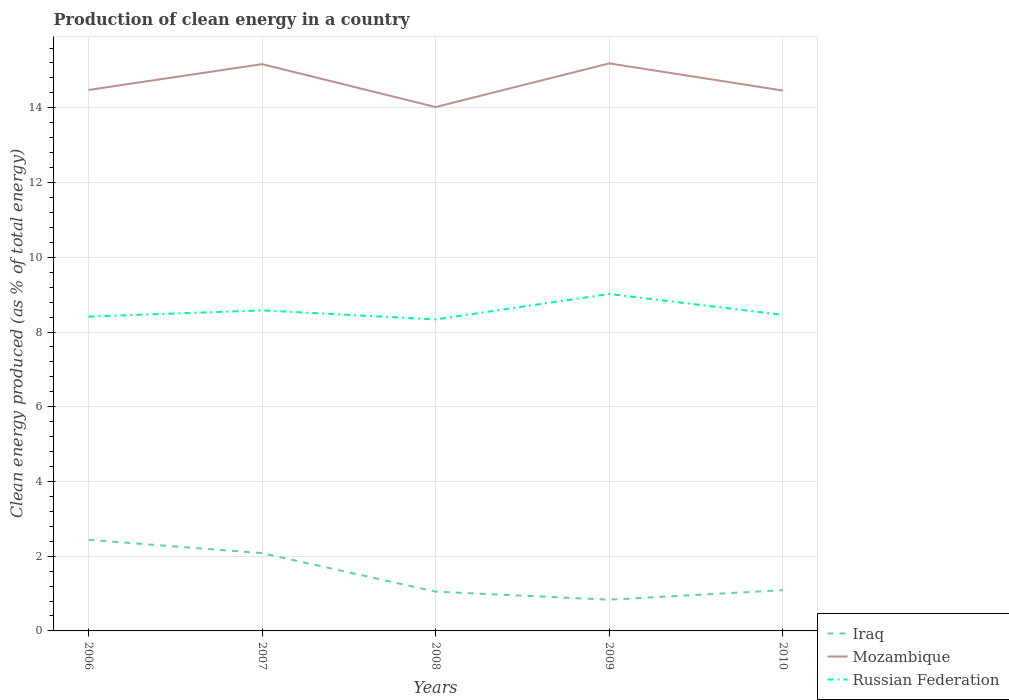Does the line corresponding to Russian Federation intersect with the line corresponding to Iraq?
Offer a very short reply. No. Across all years, what is the maximum percentage of clean energy produced in Mozambique?
Keep it short and to the point. 14.02. What is the total percentage of clean energy produced in Iraq in the graph?
Provide a short and direct response. -0.04. What is the difference between the highest and the second highest percentage of clean energy produced in Mozambique?
Provide a short and direct response. 1.17. What is the difference between the highest and the lowest percentage of clean energy produced in Russian Federation?
Keep it short and to the point. 2. Is the percentage of clean energy produced in Mozambique strictly greater than the percentage of clean energy produced in Iraq over the years?
Your answer should be compact. No. How many lines are there?
Provide a short and direct response. 3. How many years are there in the graph?
Provide a succinct answer. 5. Where does the legend appear in the graph?
Your answer should be compact. Bottom right. How many legend labels are there?
Offer a terse response. 3. What is the title of the graph?
Offer a terse response. Production of clean energy in a country. What is the label or title of the Y-axis?
Give a very brief answer. Clean energy produced (as % of total energy). What is the Clean energy produced (as % of total energy) of Iraq in 2006?
Offer a terse response. 2.44. What is the Clean energy produced (as % of total energy) in Mozambique in 2006?
Give a very brief answer. 14.48. What is the Clean energy produced (as % of total energy) of Russian Federation in 2006?
Provide a short and direct response. 8.41. What is the Clean energy produced (as % of total energy) in Iraq in 2007?
Offer a very short reply. 2.08. What is the Clean energy produced (as % of total energy) of Mozambique in 2007?
Offer a terse response. 15.17. What is the Clean energy produced (as % of total energy) of Russian Federation in 2007?
Your answer should be compact. 8.58. What is the Clean energy produced (as % of total energy) in Iraq in 2008?
Ensure brevity in your answer.  1.05. What is the Clean energy produced (as % of total energy) in Mozambique in 2008?
Your response must be concise. 14.02. What is the Clean energy produced (as % of total energy) in Russian Federation in 2008?
Your answer should be compact. 8.34. What is the Clean energy produced (as % of total energy) in Iraq in 2009?
Ensure brevity in your answer.  0.84. What is the Clean energy produced (as % of total energy) in Mozambique in 2009?
Your answer should be very brief. 15.19. What is the Clean energy produced (as % of total energy) in Russian Federation in 2009?
Offer a terse response. 9.02. What is the Clean energy produced (as % of total energy) of Iraq in 2010?
Your response must be concise. 1.09. What is the Clean energy produced (as % of total energy) of Mozambique in 2010?
Make the answer very short. 14.46. What is the Clean energy produced (as % of total energy) in Russian Federation in 2010?
Your answer should be compact. 8.46. Across all years, what is the maximum Clean energy produced (as % of total energy) of Iraq?
Keep it short and to the point. 2.44. Across all years, what is the maximum Clean energy produced (as % of total energy) in Mozambique?
Provide a succinct answer. 15.19. Across all years, what is the maximum Clean energy produced (as % of total energy) in Russian Federation?
Keep it short and to the point. 9.02. Across all years, what is the minimum Clean energy produced (as % of total energy) of Iraq?
Your response must be concise. 0.84. Across all years, what is the minimum Clean energy produced (as % of total energy) in Mozambique?
Make the answer very short. 14.02. Across all years, what is the minimum Clean energy produced (as % of total energy) in Russian Federation?
Offer a very short reply. 8.34. What is the total Clean energy produced (as % of total energy) of Iraq in the graph?
Provide a succinct answer. 7.5. What is the total Clean energy produced (as % of total energy) of Mozambique in the graph?
Make the answer very short. 73.32. What is the total Clean energy produced (as % of total energy) of Russian Federation in the graph?
Ensure brevity in your answer.  42.8. What is the difference between the Clean energy produced (as % of total energy) of Iraq in 2006 and that in 2007?
Your answer should be compact. 0.36. What is the difference between the Clean energy produced (as % of total energy) in Mozambique in 2006 and that in 2007?
Keep it short and to the point. -0.69. What is the difference between the Clean energy produced (as % of total energy) in Russian Federation in 2006 and that in 2007?
Keep it short and to the point. -0.17. What is the difference between the Clean energy produced (as % of total energy) in Iraq in 2006 and that in 2008?
Give a very brief answer. 1.39. What is the difference between the Clean energy produced (as % of total energy) of Mozambique in 2006 and that in 2008?
Offer a very short reply. 0.46. What is the difference between the Clean energy produced (as % of total energy) of Russian Federation in 2006 and that in 2008?
Your answer should be compact. 0.08. What is the difference between the Clean energy produced (as % of total energy) in Iraq in 2006 and that in 2009?
Offer a very short reply. 1.6. What is the difference between the Clean energy produced (as % of total energy) of Mozambique in 2006 and that in 2009?
Your answer should be compact. -0.71. What is the difference between the Clean energy produced (as % of total energy) in Russian Federation in 2006 and that in 2009?
Give a very brief answer. -0.6. What is the difference between the Clean energy produced (as % of total energy) of Iraq in 2006 and that in 2010?
Make the answer very short. 1.35. What is the difference between the Clean energy produced (as % of total energy) of Mozambique in 2006 and that in 2010?
Offer a very short reply. 0.01. What is the difference between the Clean energy produced (as % of total energy) of Russian Federation in 2006 and that in 2010?
Your answer should be very brief. -0.05. What is the difference between the Clean energy produced (as % of total energy) in Iraq in 2007 and that in 2008?
Offer a very short reply. 1.03. What is the difference between the Clean energy produced (as % of total energy) of Mozambique in 2007 and that in 2008?
Offer a terse response. 1.15. What is the difference between the Clean energy produced (as % of total energy) in Russian Federation in 2007 and that in 2008?
Keep it short and to the point. 0.24. What is the difference between the Clean energy produced (as % of total energy) of Iraq in 2007 and that in 2009?
Provide a succinct answer. 1.25. What is the difference between the Clean energy produced (as % of total energy) in Mozambique in 2007 and that in 2009?
Make the answer very short. -0.02. What is the difference between the Clean energy produced (as % of total energy) in Russian Federation in 2007 and that in 2009?
Offer a terse response. -0.44. What is the difference between the Clean energy produced (as % of total energy) of Iraq in 2007 and that in 2010?
Your answer should be compact. 0.99. What is the difference between the Clean energy produced (as % of total energy) in Mozambique in 2007 and that in 2010?
Your response must be concise. 0.71. What is the difference between the Clean energy produced (as % of total energy) in Russian Federation in 2007 and that in 2010?
Make the answer very short. 0.12. What is the difference between the Clean energy produced (as % of total energy) of Iraq in 2008 and that in 2009?
Offer a terse response. 0.22. What is the difference between the Clean energy produced (as % of total energy) in Mozambique in 2008 and that in 2009?
Offer a terse response. -1.17. What is the difference between the Clean energy produced (as % of total energy) in Russian Federation in 2008 and that in 2009?
Your answer should be compact. -0.68. What is the difference between the Clean energy produced (as % of total energy) of Iraq in 2008 and that in 2010?
Your answer should be very brief. -0.04. What is the difference between the Clean energy produced (as % of total energy) of Mozambique in 2008 and that in 2010?
Offer a terse response. -0.44. What is the difference between the Clean energy produced (as % of total energy) in Russian Federation in 2008 and that in 2010?
Keep it short and to the point. -0.12. What is the difference between the Clean energy produced (as % of total energy) of Iraq in 2009 and that in 2010?
Your answer should be compact. -0.26. What is the difference between the Clean energy produced (as % of total energy) of Mozambique in 2009 and that in 2010?
Your answer should be very brief. 0.73. What is the difference between the Clean energy produced (as % of total energy) in Russian Federation in 2009 and that in 2010?
Offer a terse response. 0.56. What is the difference between the Clean energy produced (as % of total energy) of Iraq in 2006 and the Clean energy produced (as % of total energy) of Mozambique in 2007?
Ensure brevity in your answer.  -12.73. What is the difference between the Clean energy produced (as % of total energy) of Iraq in 2006 and the Clean energy produced (as % of total energy) of Russian Federation in 2007?
Make the answer very short. -6.14. What is the difference between the Clean energy produced (as % of total energy) of Mozambique in 2006 and the Clean energy produced (as % of total energy) of Russian Federation in 2007?
Provide a short and direct response. 5.9. What is the difference between the Clean energy produced (as % of total energy) of Iraq in 2006 and the Clean energy produced (as % of total energy) of Mozambique in 2008?
Your answer should be very brief. -11.58. What is the difference between the Clean energy produced (as % of total energy) of Iraq in 2006 and the Clean energy produced (as % of total energy) of Russian Federation in 2008?
Keep it short and to the point. -5.9. What is the difference between the Clean energy produced (as % of total energy) of Mozambique in 2006 and the Clean energy produced (as % of total energy) of Russian Federation in 2008?
Give a very brief answer. 6.14. What is the difference between the Clean energy produced (as % of total energy) of Iraq in 2006 and the Clean energy produced (as % of total energy) of Mozambique in 2009?
Your answer should be very brief. -12.75. What is the difference between the Clean energy produced (as % of total energy) in Iraq in 2006 and the Clean energy produced (as % of total energy) in Russian Federation in 2009?
Provide a short and direct response. -6.58. What is the difference between the Clean energy produced (as % of total energy) in Mozambique in 2006 and the Clean energy produced (as % of total energy) in Russian Federation in 2009?
Keep it short and to the point. 5.46. What is the difference between the Clean energy produced (as % of total energy) in Iraq in 2006 and the Clean energy produced (as % of total energy) in Mozambique in 2010?
Your answer should be compact. -12.03. What is the difference between the Clean energy produced (as % of total energy) of Iraq in 2006 and the Clean energy produced (as % of total energy) of Russian Federation in 2010?
Offer a terse response. -6.02. What is the difference between the Clean energy produced (as % of total energy) of Mozambique in 2006 and the Clean energy produced (as % of total energy) of Russian Federation in 2010?
Provide a short and direct response. 6.02. What is the difference between the Clean energy produced (as % of total energy) in Iraq in 2007 and the Clean energy produced (as % of total energy) in Mozambique in 2008?
Your response must be concise. -11.94. What is the difference between the Clean energy produced (as % of total energy) in Iraq in 2007 and the Clean energy produced (as % of total energy) in Russian Federation in 2008?
Offer a terse response. -6.26. What is the difference between the Clean energy produced (as % of total energy) of Mozambique in 2007 and the Clean energy produced (as % of total energy) of Russian Federation in 2008?
Ensure brevity in your answer.  6.83. What is the difference between the Clean energy produced (as % of total energy) of Iraq in 2007 and the Clean energy produced (as % of total energy) of Mozambique in 2009?
Provide a succinct answer. -13.11. What is the difference between the Clean energy produced (as % of total energy) in Iraq in 2007 and the Clean energy produced (as % of total energy) in Russian Federation in 2009?
Offer a terse response. -6.94. What is the difference between the Clean energy produced (as % of total energy) in Mozambique in 2007 and the Clean energy produced (as % of total energy) in Russian Federation in 2009?
Provide a short and direct response. 6.15. What is the difference between the Clean energy produced (as % of total energy) of Iraq in 2007 and the Clean energy produced (as % of total energy) of Mozambique in 2010?
Make the answer very short. -12.38. What is the difference between the Clean energy produced (as % of total energy) of Iraq in 2007 and the Clean energy produced (as % of total energy) of Russian Federation in 2010?
Provide a short and direct response. -6.38. What is the difference between the Clean energy produced (as % of total energy) in Mozambique in 2007 and the Clean energy produced (as % of total energy) in Russian Federation in 2010?
Ensure brevity in your answer.  6.71. What is the difference between the Clean energy produced (as % of total energy) in Iraq in 2008 and the Clean energy produced (as % of total energy) in Mozambique in 2009?
Your answer should be very brief. -14.14. What is the difference between the Clean energy produced (as % of total energy) in Iraq in 2008 and the Clean energy produced (as % of total energy) in Russian Federation in 2009?
Provide a succinct answer. -7.97. What is the difference between the Clean energy produced (as % of total energy) of Mozambique in 2008 and the Clean energy produced (as % of total energy) of Russian Federation in 2009?
Make the answer very short. 5. What is the difference between the Clean energy produced (as % of total energy) of Iraq in 2008 and the Clean energy produced (as % of total energy) of Mozambique in 2010?
Your answer should be compact. -13.41. What is the difference between the Clean energy produced (as % of total energy) in Iraq in 2008 and the Clean energy produced (as % of total energy) in Russian Federation in 2010?
Keep it short and to the point. -7.41. What is the difference between the Clean energy produced (as % of total energy) in Mozambique in 2008 and the Clean energy produced (as % of total energy) in Russian Federation in 2010?
Provide a short and direct response. 5.56. What is the difference between the Clean energy produced (as % of total energy) of Iraq in 2009 and the Clean energy produced (as % of total energy) of Mozambique in 2010?
Give a very brief answer. -13.63. What is the difference between the Clean energy produced (as % of total energy) of Iraq in 2009 and the Clean energy produced (as % of total energy) of Russian Federation in 2010?
Your response must be concise. -7.62. What is the difference between the Clean energy produced (as % of total energy) in Mozambique in 2009 and the Clean energy produced (as % of total energy) in Russian Federation in 2010?
Your answer should be very brief. 6.73. What is the average Clean energy produced (as % of total energy) of Iraq per year?
Give a very brief answer. 1.5. What is the average Clean energy produced (as % of total energy) of Mozambique per year?
Make the answer very short. 14.66. What is the average Clean energy produced (as % of total energy) in Russian Federation per year?
Ensure brevity in your answer.  8.56. In the year 2006, what is the difference between the Clean energy produced (as % of total energy) of Iraq and Clean energy produced (as % of total energy) of Mozambique?
Your response must be concise. -12.04. In the year 2006, what is the difference between the Clean energy produced (as % of total energy) of Iraq and Clean energy produced (as % of total energy) of Russian Federation?
Give a very brief answer. -5.97. In the year 2006, what is the difference between the Clean energy produced (as % of total energy) in Mozambique and Clean energy produced (as % of total energy) in Russian Federation?
Provide a succinct answer. 6.06. In the year 2007, what is the difference between the Clean energy produced (as % of total energy) in Iraq and Clean energy produced (as % of total energy) in Mozambique?
Make the answer very short. -13.09. In the year 2007, what is the difference between the Clean energy produced (as % of total energy) of Iraq and Clean energy produced (as % of total energy) of Russian Federation?
Provide a succinct answer. -6.5. In the year 2007, what is the difference between the Clean energy produced (as % of total energy) in Mozambique and Clean energy produced (as % of total energy) in Russian Federation?
Ensure brevity in your answer.  6.59. In the year 2008, what is the difference between the Clean energy produced (as % of total energy) in Iraq and Clean energy produced (as % of total energy) in Mozambique?
Offer a terse response. -12.97. In the year 2008, what is the difference between the Clean energy produced (as % of total energy) in Iraq and Clean energy produced (as % of total energy) in Russian Federation?
Give a very brief answer. -7.29. In the year 2008, what is the difference between the Clean energy produced (as % of total energy) in Mozambique and Clean energy produced (as % of total energy) in Russian Federation?
Provide a short and direct response. 5.68. In the year 2009, what is the difference between the Clean energy produced (as % of total energy) of Iraq and Clean energy produced (as % of total energy) of Mozambique?
Your answer should be very brief. -14.35. In the year 2009, what is the difference between the Clean energy produced (as % of total energy) in Iraq and Clean energy produced (as % of total energy) in Russian Federation?
Your answer should be compact. -8.18. In the year 2009, what is the difference between the Clean energy produced (as % of total energy) in Mozambique and Clean energy produced (as % of total energy) in Russian Federation?
Your response must be concise. 6.17. In the year 2010, what is the difference between the Clean energy produced (as % of total energy) of Iraq and Clean energy produced (as % of total energy) of Mozambique?
Offer a very short reply. -13.37. In the year 2010, what is the difference between the Clean energy produced (as % of total energy) in Iraq and Clean energy produced (as % of total energy) in Russian Federation?
Keep it short and to the point. -7.37. In the year 2010, what is the difference between the Clean energy produced (as % of total energy) in Mozambique and Clean energy produced (as % of total energy) in Russian Federation?
Your answer should be very brief. 6. What is the ratio of the Clean energy produced (as % of total energy) of Iraq in 2006 to that in 2007?
Make the answer very short. 1.17. What is the ratio of the Clean energy produced (as % of total energy) of Mozambique in 2006 to that in 2007?
Offer a terse response. 0.95. What is the ratio of the Clean energy produced (as % of total energy) of Russian Federation in 2006 to that in 2007?
Make the answer very short. 0.98. What is the ratio of the Clean energy produced (as % of total energy) in Iraq in 2006 to that in 2008?
Offer a terse response. 2.32. What is the ratio of the Clean energy produced (as % of total energy) in Mozambique in 2006 to that in 2008?
Offer a very short reply. 1.03. What is the ratio of the Clean energy produced (as % of total energy) in Russian Federation in 2006 to that in 2008?
Provide a succinct answer. 1.01. What is the ratio of the Clean energy produced (as % of total energy) of Iraq in 2006 to that in 2009?
Your answer should be very brief. 2.92. What is the ratio of the Clean energy produced (as % of total energy) in Mozambique in 2006 to that in 2009?
Your answer should be compact. 0.95. What is the ratio of the Clean energy produced (as % of total energy) of Russian Federation in 2006 to that in 2009?
Offer a very short reply. 0.93. What is the ratio of the Clean energy produced (as % of total energy) in Iraq in 2006 to that in 2010?
Your answer should be compact. 2.23. What is the ratio of the Clean energy produced (as % of total energy) of Iraq in 2007 to that in 2008?
Ensure brevity in your answer.  1.98. What is the ratio of the Clean energy produced (as % of total energy) of Mozambique in 2007 to that in 2008?
Keep it short and to the point. 1.08. What is the ratio of the Clean energy produced (as % of total energy) in Russian Federation in 2007 to that in 2008?
Provide a short and direct response. 1.03. What is the ratio of the Clean energy produced (as % of total energy) of Iraq in 2007 to that in 2009?
Provide a short and direct response. 2.49. What is the ratio of the Clean energy produced (as % of total energy) in Mozambique in 2007 to that in 2009?
Offer a terse response. 1. What is the ratio of the Clean energy produced (as % of total energy) of Russian Federation in 2007 to that in 2009?
Make the answer very short. 0.95. What is the ratio of the Clean energy produced (as % of total energy) in Iraq in 2007 to that in 2010?
Give a very brief answer. 1.91. What is the ratio of the Clean energy produced (as % of total energy) in Mozambique in 2007 to that in 2010?
Offer a very short reply. 1.05. What is the ratio of the Clean energy produced (as % of total energy) of Russian Federation in 2007 to that in 2010?
Offer a very short reply. 1.01. What is the ratio of the Clean energy produced (as % of total energy) of Iraq in 2008 to that in 2009?
Provide a short and direct response. 1.26. What is the ratio of the Clean energy produced (as % of total energy) in Mozambique in 2008 to that in 2009?
Your answer should be compact. 0.92. What is the ratio of the Clean energy produced (as % of total energy) of Russian Federation in 2008 to that in 2009?
Make the answer very short. 0.92. What is the ratio of the Clean energy produced (as % of total energy) of Iraq in 2008 to that in 2010?
Your answer should be very brief. 0.96. What is the ratio of the Clean energy produced (as % of total energy) of Mozambique in 2008 to that in 2010?
Your response must be concise. 0.97. What is the ratio of the Clean energy produced (as % of total energy) of Russian Federation in 2008 to that in 2010?
Your answer should be very brief. 0.99. What is the ratio of the Clean energy produced (as % of total energy) of Iraq in 2009 to that in 2010?
Give a very brief answer. 0.77. What is the ratio of the Clean energy produced (as % of total energy) of Mozambique in 2009 to that in 2010?
Provide a short and direct response. 1.05. What is the ratio of the Clean energy produced (as % of total energy) in Russian Federation in 2009 to that in 2010?
Provide a succinct answer. 1.07. What is the difference between the highest and the second highest Clean energy produced (as % of total energy) in Iraq?
Your response must be concise. 0.36. What is the difference between the highest and the second highest Clean energy produced (as % of total energy) of Mozambique?
Keep it short and to the point. 0.02. What is the difference between the highest and the second highest Clean energy produced (as % of total energy) in Russian Federation?
Provide a succinct answer. 0.44. What is the difference between the highest and the lowest Clean energy produced (as % of total energy) in Iraq?
Give a very brief answer. 1.6. What is the difference between the highest and the lowest Clean energy produced (as % of total energy) of Mozambique?
Offer a terse response. 1.17. What is the difference between the highest and the lowest Clean energy produced (as % of total energy) in Russian Federation?
Make the answer very short. 0.68. 